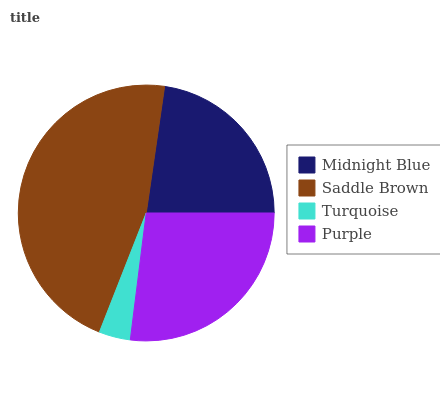Is Turquoise the minimum?
Answer yes or no. Yes. Is Saddle Brown the maximum?
Answer yes or no. Yes. Is Saddle Brown the minimum?
Answer yes or no. No. Is Turquoise the maximum?
Answer yes or no. No. Is Saddle Brown greater than Turquoise?
Answer yes or no. Yes. Is Turquoise less than Saddle Brown?
Answer yes or no. Yes. Is Turquoise greater than Saddle Brown?
Answer yes or no. No. Is Saddle Brown less than Turquoise?
Answer yes or no. No. Is Purple the high median?
Answer yes or no. Yes. Is Midnight Blue the low median?
Answer yes or no. Yes. Is Midnight Blue the high median?
Answer yes or no. No. Is Saddle Brown the low median?
Answer yes or no. No. 